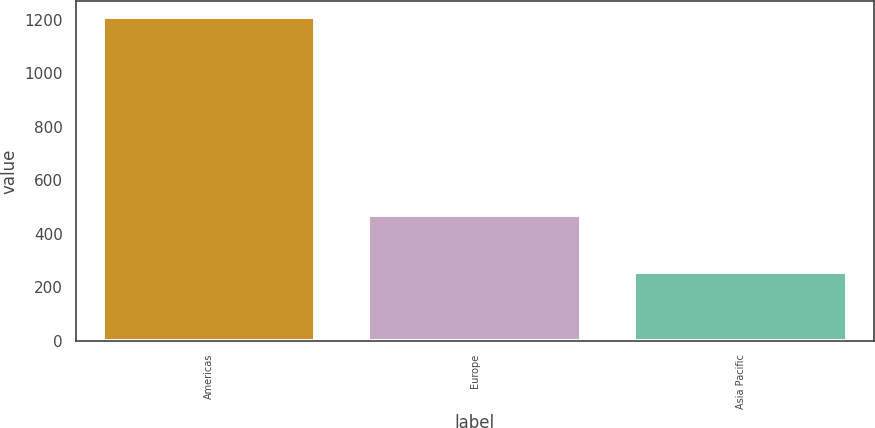<chart> <loc_0><loc_0><loc_500><loc_500><bar_chart><fcel>Americas<fcel>Europe<fcel>Asia Pacific<nl><fcel>1209.4<fcel>470.2<fcel>257.1<nl></chart> 